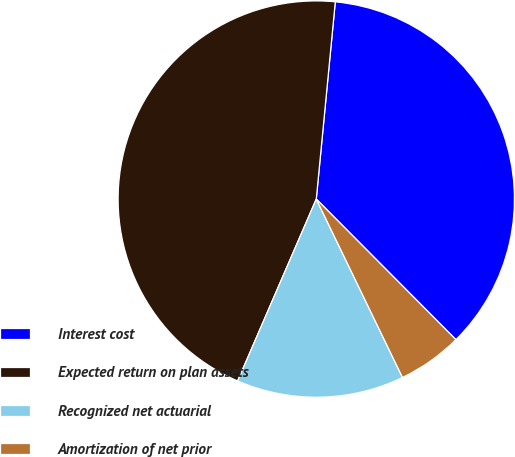Convert chart. <chart><loc_0><loc_0><loc_500><loc_500><pie_chart><fcel>Interest cost<fcel>Expected return on plan assets<fcel>Recognized net actuarial<fcel>Amortization of net prior<nl><fcel>36.02%<fcel>45.03%<fcel>13.66%<fcel>5.28%<nl></chart> 